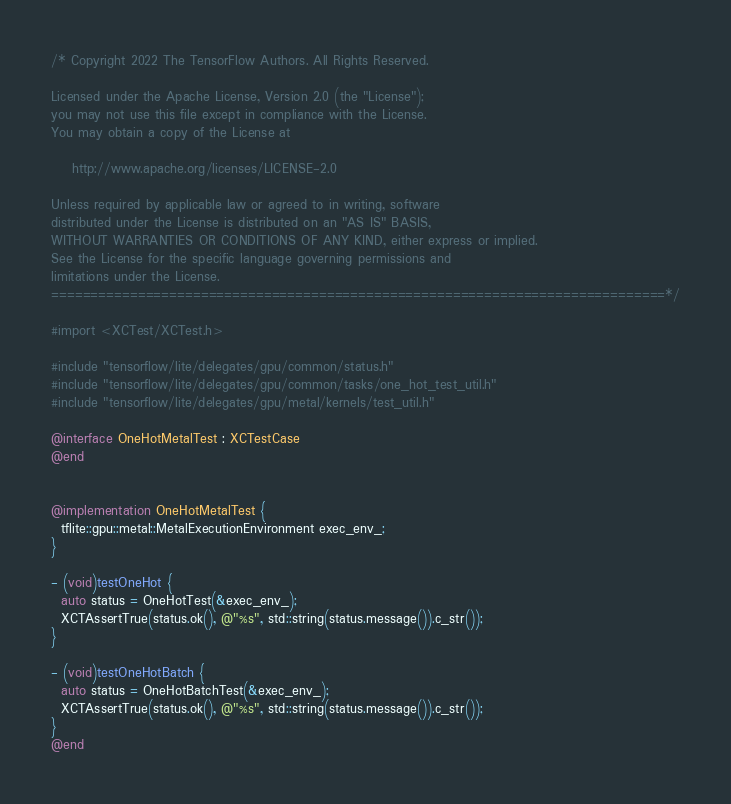Convert code to text. <code><loc_0><loc_0><loc_500><loc_500><_ObjectiveC_>/* Copyright 2022 The TensorFlow Authors. All Rights Reserved.

Licensed under the Apache License, Version 2.0 (the "License");
you may not use this file except in compliance with the License.
You may obtain a copy of the License at

    http://www.apache.org/licenses/LICENSE-2.0

Unless required by applicable law or agreed to in writing, software
distributed under the License is distributed on an "AS IS" BASIS,
WITHOUT WARRANTIES OR CONDITIONS OF ANY KIND, either express or implied.
See the License for the specific language governing permissions and
limitations under the License.
==============================================================================*/

#import <XCTest/XCTest.h>

#include "tensorflow/lite/delegates/gpu/common/status.h"
#include "tensorflow/lite/delegates/gpu/common/tasks/one_hot_test_util.h"
#include "tensorflow/lite/delegates/gpu/metal/kernels/test_util.h"

@interface OneHotMetalTest : XCTestCase
@end


@implementation OneHotMetalTest {
  tflite::gpu::metal::MetalExecutionEnvironment exec_env_;
}

- (void)testOneHot {
  auto status = OneHotTest(&exec_env_);
  XCTAssertTrue(status.ok(), @"%s", std::string(status.message()).c_str());
}

- (void)testOneHotBatch {
  auto status = OneHotBatchTest(&exec_env_);
  XCTAssertTrue(status.ok(), @"%s", std::string(status.message()).c_str());
}
@end
</code> 